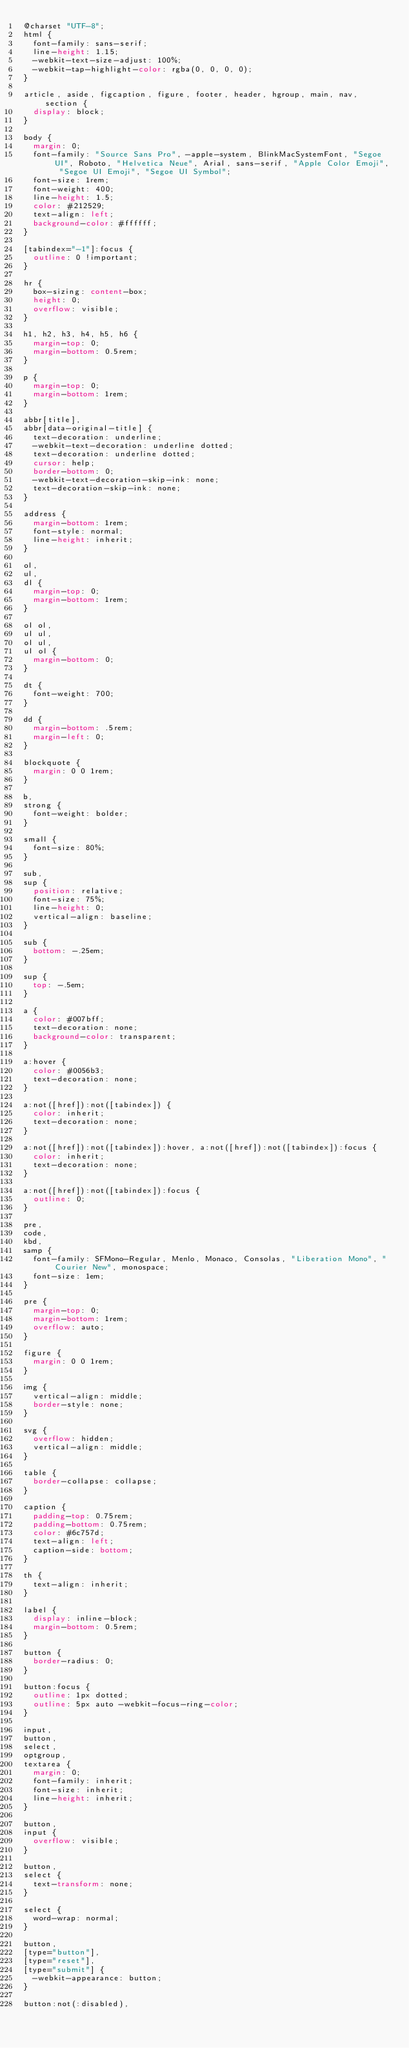<code> <loc_0><loc_0><loc_500><loc_500><_CSS_>@charset "UTF-8";
html {
  font-family: sans-serif;
  line-height: 1.15;
  -webkit-text-size-adjust: 100%;
  -webkit-tap-highlight-color: rgba(0, 0, 0, 0);
}

article, aside, figcaption, figure, footer, header, hgroup, main, nav, section {
  display: block;
}

body {
  margin: 0;
  font-family: "Source Sans Pro", -apple-system, BlinkMacSystemFont, "Segoe UI", Roboto, "Helvetica Neue", Arial, sans-serif, "Apple Color Emoji", "Segoe UI Emoji", "Segoe UI Symbol";
  font-size: 1rem;
  font-weight: 400;
  line-height: 1.5;
  color: #212529;
  text-align: left;
  background-color: #ffffff;
}

[tabindex="-1"]:focus {
  outline: 0 !important;
}

hr {
  box-sizing: content-box;
  height: 0;
  overflow: visible;
}

h1, h2, h3, h4, h5, h6 {
  margin-top: 0;
  margin-bottom: 0.5rem;
}

p {
  margin-top: 0;
  margin-bottom: 1rem;
}

abbr[title],
abbr[data-original-title] {
  text-decoration: underline;
  -webkit-text-decoration: underline dotted;
  text-decoration: underline dotted;
  cursor: help;
  border-bottom: 0;
  -webkit-text-decoration-skip-ink: none;
  text-decoration-skip-ink: none;
}

address {
  margin-bottom: 1rem;
  font-style: normal;
  line-height: inherit;
}

ol,
ul,
dl {
  margin-top: 0;
  margin-bottom: 1rem;
}

ol ol,
ul ul,
ol ul,
ul ol {
  margin-bottom: 0;
}

dt {
  font-weight: 700;
}

dd {
  margin-bottom: .5rem;
  margin-left: 0;
}

blockquote {
  margin: 0 0 1rem;
}

b,
strong {
  font-weight: bolder;
}

small {
  font-size: 80%;
}

sub,
sup {
  position: relative;
  font-size: 75%;
  line-height: 0;
  vertical-align: baseline;
}

sub {
  bottom: -.25em;
}

sup {
  top: -.5em;
}

a {
  color: #007bff;
  text-decoration: none;
  background-color: transparent;
}

a:hover {
  color: #0056b3;
  text-decoration: none;
}

a:not([href]):not([tabindex]) {
  color: inherit;
  text-decoration: none;
}

a:not([href]):not([tabindex]):hover, a:not([href]):not([tabindex]):focus {
  color: inherit;
  text-decoration: none;
}

a:not([href]):not([tabindex]):focus {
  outline: 0;
}

pre,
code,
kbd,
samp {
  font-family: SFMono-Regular, Menlo, Monaco, Consolas, "Liberation Mono", "Courier New", monospace;
  font-size: 1em;
}

pre {
  margin-top: 0;
  margin-bottom: 1rem;
  overflow: auto;
}

figure {
  margin: 0 0 1rem;
}

img {
  vertical-align: middle;
  border-style: none;
}

svg {
  overflow: hidden;
  vertical-align: middle;
}

table {
  border-collapse: collapse;
}

caption {
  padding-top: 0.75rem;
  padding-bottom: 0.75rem;
  color: #6c757d;
  text-align: left;
  caption-side: bottom;
}

th {
  text-align: inherit;
}

label {
  display: inline-block;
  margin-bottom: 0.5rem;
}

button {
  border-radius: 0;
}

button:focus {
  outline: 1px dotted;
  outline: 5px auto -webkit-focus-ring-color;
}

input,
button,
select,
optgroup,
textarea {
  margin: 0;
  font-family: inherit;
  font-size: inherit;
  line-height: inherit;
}

button,
input {
  overflow: visible;
}

button,
select {
  text-transform: none;
}

select {
  word-wrap: normal;
}

button,
[type="button"],
[type="reset"],
[type="submit"] {
  -webkit-appearance: button;
}

button:not(:disabled),</code> 